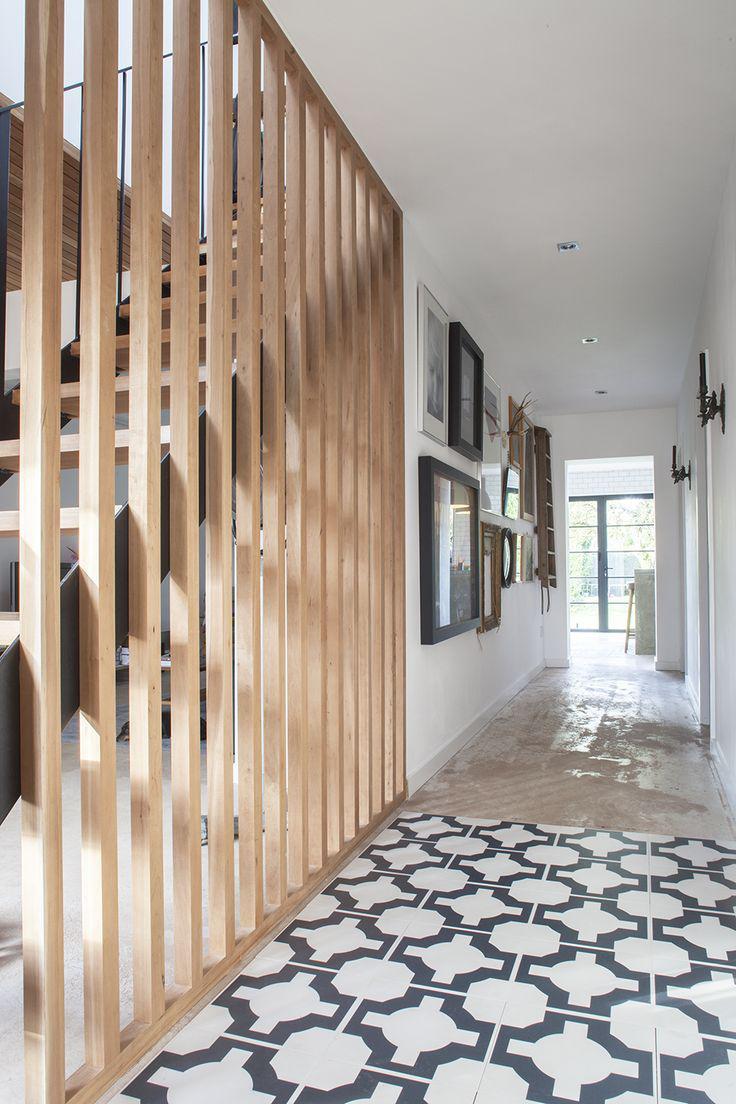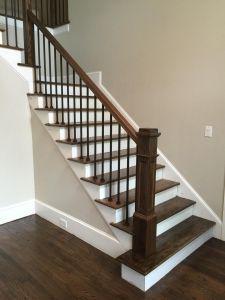The first image is the image on the left, the second image is the image on the right. Examine the images to the left and right. Is the description "The staircases in both images have metal railings." accurate? Answer yes or no. No. The first image is the image on the left, the second image is the image on the right. Evaluate the accuracy of this statement regarding the images: "One set of stairs has partly silver colored railings.". Is it true? Answer yes or no. No. 